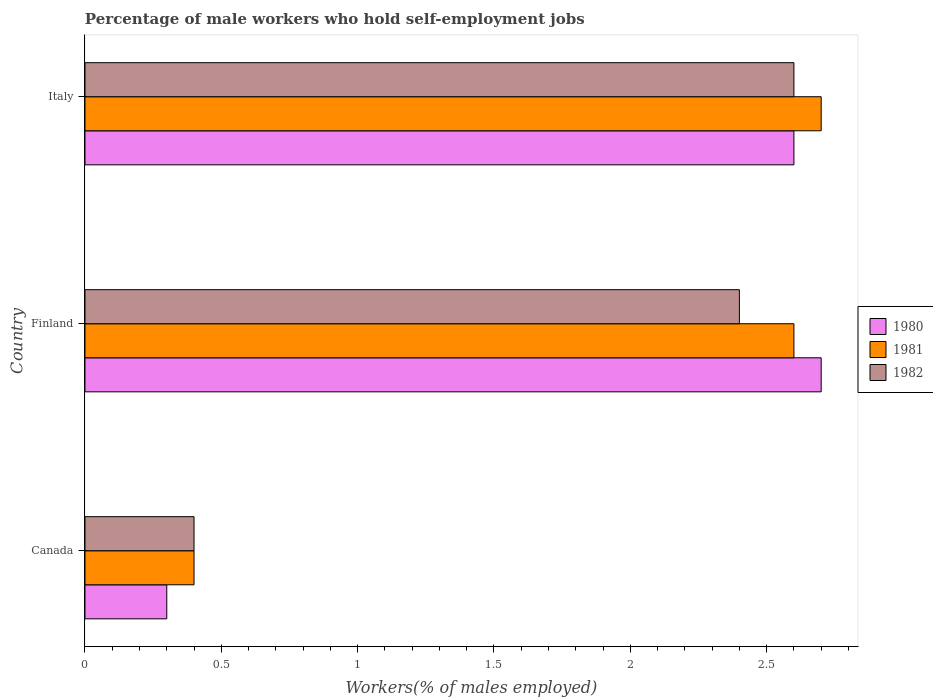How many groups of bars are there?
Your answer should be very brief. 3. Are the number of bars on each tick of the Y-axis equal?
Offer a terse response. Yes. What is the label of the 3rd group of bars from the top?
Provide a short and direct response. Canada. In how many cases, is the number of bars for a given country not equal to the number of legend labels?
Keep it short and to the point. 0. What is the percentage of self-employed male workers in 1982 in Canada?
Keep it short and to the point. 0.4. Across all countries, what is the maximum percentage of self-employed male workers in 1981?
Offer a very short reply. 2.7. Across all countries, what is the minimum percentage of self-employed male workers in 1982?
Offer a very short reply. 0.4. In which country was the percentage of self-employed male workers in 1981 maximum?
Keep it short and to the point. Italy. What is the total percentage of self-employed male workers in 1982 in the graph?
Make the answer very short. 5.4. What is the difference between the percentage of self-employed male workers in 1981 in Canada and that in Italy?
Give a very brief answer. -2.3. What is the difference between the percentage of self-employed male workers in 1982 in Italy and the percentage of self-employed male workers in 1981 in Finland?
Your answer should be compact. 0. What is the average percentage of self-employed male workers in 1981 per country?
Ensure brevity in your answer.  1.9. What is the difference between the percentage of self-employed male workers in 1982 and percentage of self-employed male workers in 1981 in Italy?
Provide a succinct answer. -0.1. What is the ratio of the percentage of self-employed male workers in 1982 in Finland to that in Italy?
Keep it short and to the point. 0.92. Is the difference between the percentage of self-employed male workers in 1982 in Canada and Finland greater than the difference between the percentage of self-employed male workers in 1981 in Canada and Finland?
Your answer should be very brief. Yes. What is the difference between the highest and the second highest percentage of self-employed male workers in 1982?
Give a very brief answer. 0.2. What is the difference between the highest and the lowest percentage of self-employed male workers in 1980?
Offer a very short reply. 2.4. In how many countries, is the percentage of self-employed male workers in 1981 greater than the average percentage of self-employed male workers in 1981 taken over all countries?
Make the answer very short. 2. What does the 2nd bar from the bottom in Italy represents?
Provide a succinct answer. 1981. Are all the bars in the graph horizontal?
Make the answer very short. Yes. What is the difference between two consecutive major ticks on the X-axis?
Offer a very short reply. 0.5. Are the values on the major ticks of X-axis written in scientific E-notation?
Your answer should be very brief. No. What is the title of the graph?
Give a very brief answer. Percentage of male workers who hold self-employment jobs. What is the label or title of the X-axis?
Offer a very short reply. Workers(% of males employed). What is the Workers(% of males employed) in 1980 in Canada?
Offer a terse response. 0.3. What is the Workers(% of males employed) in 1981 in Canada?
Provide a short and direct response. 0.4. What is the Workers(% of males employed) in 1982 in Canada?
Offer a very short reply. 0.4. What is the Workers(% of males employed) in 1980 in Finland?
Give a very brief answer. 2.7. What is the Workers(% of males employed) of 1981 in Finland?
Provide a succinct answer. 2.6. What is the Workers(% of males employed) of 1982 in Finland?
Provide a succinct answer. 2.4. What is the Workers(% of males employed) of 1980 in Italy?
Give a very brief answer. 2.6. What is the Workers(% of males employed) of 1981 in Italy?
Ensure brevity in your answer.  2.7. What is the Workers(% of males employed) in 1982 in Italy?
Your response must be concise. 2.6. Across all countries, what is the maximum Workers(% of males employed) in 1980?
Provide a short and direct response. 2.7. Across all countries, what is the maximum Workers(% of males employed) in 1981?
Make the answer very short. 2.7. Across all countries, what is the maximum Workers(% of males employed) in 1982?
Make the answer very short. 2.6. Across all countries, what is the minimum Workers(% of males employed) of 1980?
Your answer should be very brief. 0.3. Across all countries, what is the minimum Workers(% of males employed) of 1981?
Give a very brief answer. 0.4. Across all countries, what is the minimum Workers(% of males employed) in 1982?
Your response must be concise. 0.4. What is the total Workers(% of males employed) of 1980 in the graph?
Offer a terse response. 5.6. What is the total Workers(% of males employed) of 1982 in the graph?
Your answer should be very brief. 5.4. What is the difference between the Workers(% of males employed) in 1981 in Canada and that in Finland?
Keep it short and to the point. -2.2. What is the difference between the Workers(% of males employed) of 1980 in Canada and that in Italy?
Give a very brief answer. -2.3. What is the difference between the Workers(% of males employed) of 1981 in Canada and that in Italy?
Provide a succinct answer. -2.3. What is the difference between the Workers(% of males employed) of 1982 in Finland and that in Italy?
Your answer should be compact. -0.2. What is the difference between the Workers(% of males employed) of 1980 in Canada and the Workers(% of males employed) of 1982 in Finland?
Keep it short and to the point. -2.1. What is the difference between the Workers(% of males employed) of 1980 in Canada and the Workers(% of males employed) of 1981 in Italy?
Offer a very short reply. -2.4. What is the difference between the Workers(% of males employed) in 1981 in Canada and the Workers(% of males employed) in 1982 in Italy?
Give a very brief answer. -2.2. What is the difference between the Workers(% of males employed) in 1980 in Finland and the Workers(% of males employed) in 1982 in Italy?
Ensure brevity in your answer.  0.1. What is the average Workers(% of males employed) in 1980 per country?
Give a very brief answer. 1.87. What is the average Workers(% of males employed) in 1981 per country?
Provide a succinct answer. 1.9. What is the average Workers(% of males employed) of 1982 per country?
Your answer should be very brief. 1.8. What is the difference between the Workers(% of males employed) in 1980 and Workers(% of males employed) in 1982 in Canada?
Your answer should be very brief. -0.1. What is the difference between the Workers(% of males employed) in 1980 and Workers(% of males employed) in 1981 in Finland?
Your answer should be compact. 0.1. What is the difference between the Workers(% of males employed) of 1980 and Workers(% of males employed) of 1982 in Finland?
Offer a very short reply. 0.3. What is the difference between the Workers(% of males employed) of 1980 and Workers(% of males employed) of 1981 in Italy?
Your answer should be very brief. -0.1. What is the difference between the Workers(% of males employed) in 1981 and Workers(% of males employed) in 1982 in Italy?
Make the answer very short. 0.1. What is the ratio of the Workers(% of males employed) of 1981 in Canada to that in Finland?
Offer a very short reply. 0.15. What is the ratio of the Workers(% of males employed) of 1980 in Canada to that in Italy?
Provide a succinct answer. 0.12. What is the ratio of the Workers(% of males employed) in 1981 in Canada to that in Italy?
Offer a terse response. 0.15. What is the ratio of the Workers(% of males employed) in 1982 in Canada to that in Italy?
Your response must be concise. 0.15. What is the ratio of the Workers(% of males employed) of 1980 in Finland to that in Italy?
Offer a very short reply. 1.04. What is the ratio of the Workers(% of males employed) of 1981 in Finland to that in Italy?
Make the answer very short. 0.96. What is the ratio of the Workers(% of males employed) of 1982 in Finland to that in Italy?
Ensure brevity in your answer.  0.92. What is the difference between the highest and the second highest Workers(% of males employed) of 1981?
Your answer should be very brief. 0.1. What is the difference between the highest and the lowest Workers(% of males employed) in 1980?
Your answer should be compact. 2.4. What is the difference between the highest and the lowest Workers(% of males employed) in 1981?
Provide a succinct answer. 2.3. 